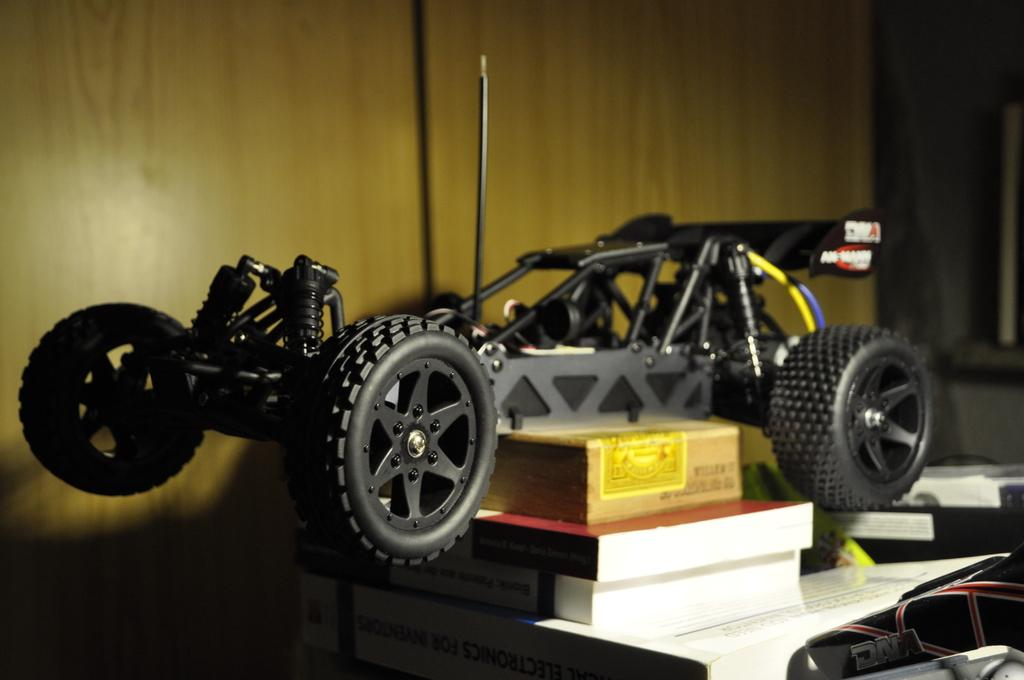What is the main object in the middle of the image? There is a toy in the middle of the image. What can be seen in the background of the image? There is a wall in the background of the image. What other items are visible at the bottom of the image? There are books at the bottom of the image. What type of food is being prepared in the image? There is no food preparation visible in the image; it features a toy in the middle, a wall in the background, and books at the bottom. 